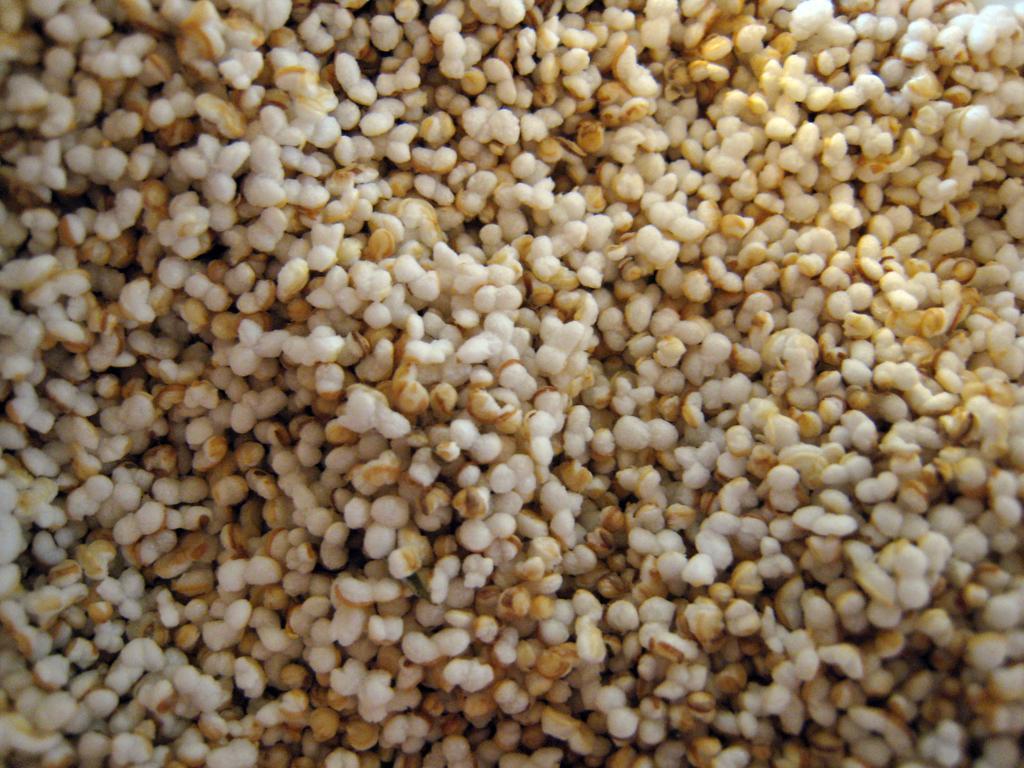Can you describe this image briefly? In the picture we can see grains. 